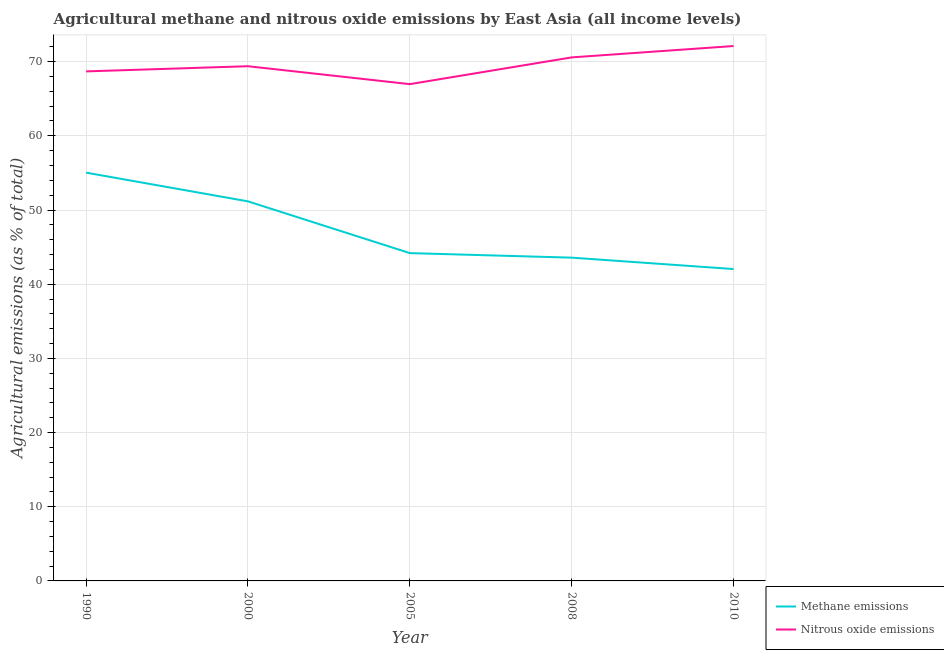Is the number of lines equal to the number of legend labels?
Your response must be concise. Yes. What is the amount of nitrous oxide emissions in 2000?
Make the answer very short. 69.38. Across all years, what is the maximum amount of methane emissions?
Offer a very short reply. 55.04. Across all years, what is the minimum amount of nitrous oxide emissions?
Your answer should be compact. 66.97. In which year was the amount of methane emissions maximum?
Your answer should be compact. 1990. What is the total amount of nitrous oxide emissions in the graph?
Offer a very short reply. 347.72. What is the difference between the amount of methane emissions in 2000 and that in 2010?
Offer a terse response. 9.13. What is the difference between the amount of methane emissions in 2008 and the amount of nitrous oxide emissions in 2000?
Offer a terse response. -25.8. What is the average amount of methane emissions per year?
Your answer should be very brief. 47.2. In the year 2000, what is the difference between the amount of nitrous oxide emissions and amount of methane emissions?
Provide a succinct answer. 18.22. In how many years, is the amount of methane emissions greater than 52 %?
Your answer should be compact. 1. What is the ratio of the amount of nitrous oxide emissions in 1990 to that in 2005?
Your answer should be very brief. 1.03. Is the amount of nitrous oxide emissions in 2005 less than that in 2008?
Keep it short and to the point. Yes. What is the difference between the highest and the second highest amount of nitrous oxide emissions?
Give a very brief answer. 1.53. What is the difference between the highest and the lowest amount of methane emissions?
Your answer should be compact. 13. How many years are there in the graph?
Your response must be concise. 5. What is the difference between two consecutive major ticks on the Y-axis?
Provide a succinct answer. 10. Does the graph contain any zero values?
Provide a short and direct response. No. Does the graph contain grids?
Your answer should be compact. Yes. How many legend labels are there?
Ensure brevity in your answer.  2. How are the legend labels stacked?
Ensure brevity in your answer.  Vertical. What is the title of the graph?
Offer a terse response. Agricultural methane and nitrous oxide emissions by East Asia (all income levels). What is the label or title of the Y-axis?
Provide a short and direct response. Agricultural emissions (as % of total). What is the Agricultural emissions (as % of total) in Methane emissions in 1990?
Your response must be concise. 55.04. What is the Agricultural emissions (as % of total) in Nitrous oxide emissions in 1990?
Provide a succinct answer. 68.69. What is the Agricultural emissions (as % of total) of Methane emissions in 2000?
Offer a very short reply. 51.17. What is the Agricultural emissions (as % of total) of Nitrous oxide emissions in 2000?
Offer a terse response. 69.38. What is the Agricultural emissions (as % of total) of Methane emissions in 2005?
Your answer should be very brief. 44.19. What is the Agricultural emissions (as % of total) in Nitrous oxide emissions in 2005?
Offer a very short reply. 66.97. What is the Agricultural emissions (as % of total) of Methane emissions in 2008?
Offer a terse response. 43.58. What is the Agricultural emissions (as % of total) in Nitrous oxide emissions in 2008?
Your answer should be very brief. 70.57. What is the Agricultural emissions (as % of total) of Methane emissions in 2010?
Make the answer very short. 42.04. What is the Agricultural emissions (as % of total) of Nitrous oxide emissions in 2010?
Provide a succinct answer. 72.11. Across all years, what is the maximum Agricultural emissions (as % of total) in Methane emissions?
Provide a succinct answer. 55.04. Across all years, what is the maximum Agricultural emissions (as % of total) in Nitrous oxide emissions?
Your response must be concise. 72.11. Across all years, what is the minimum Agricultural emissions (as % of total) of Methane emissions?
Offer a very short reply. 42.04. Across all years, what is the minimum Agricultural emissions (as % of total) in Nitrous oxide emissions?
Your answer should be compact. 66.97. What is the total Agricultural emissions (as % of total) of Methane emissions in the graph?
Offer a very short reply. 236.01. What is the total Agricultural emissions (as % of total) in Nitrous oxide emissions in the graph?
Make the answer very short. 347.72. What is the difference between the Agricultural emissions (as % of total) in Methane emissions in 1990 and that in 2000?
Your response must be concise. 3.87. What is the difference between the Agricultural emissions (as % of total) in Nitrous oxide emissions in 1990 and that in 2000?
Offer a very short reply. -0.7. What is the difference between the Agricultural emissions (as % of total) in Methane emissions in 1990 and that in 2005?
Provide a short and direct response. 10.85. What is the difference between the Agricultural emissions (as % of total) of Nitrous oxide emissions in 1990 and that in 2005?
Your answer should be compact. 1.72. What is the difference between the Agricultural emissions (as % of total) in Methane emissions in 1990 and that in 2008?
Offer a very short reply. 11.46. What is the difference between the Agricultural emissions (as % of total) in Nitrous oxide emissions in 1990 and that in 2008?
Your response must be concise. -1.89. What is the difference between the Agricultural emissions (as % of total) in Methane emissions in 1990 and that in 2010?
Offer a very short reply. 13. What is the difference between the Agricultural emissions (as % of total) in Nitrous oxide emissions in 1990 and that in 2010?
Your answer should be very brief. -3.42. What is the difference between the Agricultural emissions (as % of total) in Methane emissions in 2000 and that in 2005?
Offer a very short reply. 6.98. What is the difference between the Agricultural emissions (as % of total) in Nitrous oxide emissions in 2000 and that in 2005?
Offer a terse response. 2.41. What is the difference between the Agricultural emissions (as % of total) in Methane emissions in 2000 and that in 2008?
Give a very brief answer. 7.59. What is the difference between the Agricultural emissions (as % of total) of Nitrous oxide emissions in 2000 and that in 2008?
Make the answer very short. -1.19. What is the difference between the Agricultural emissions (as % of total) of Methane emissions in 2000 and that in 2010?
Offer a very short reply. 9.13. What is the difference between the Agricultural emissions (as % of total) in Nitrous oxide emissions in 2000 and that in 2010?
Your answer should be very brief. -2.72. What is the difference between the Agricultural emissions (as % of total) of Methane emissions in 2005 and that in 2008?
Keep it short and to the point. 0.61. What is the difference between the Agricultural emissions (as % of total) of Nitrous oxide emissions in 2005 and that in 2008?
Your response must be concise. -3.61. What is the difference between the Agricultural emissions (as % of total) in Methane emissions in 2005 and that in 2010?
Offer a very short reply. 2.15. What is the difference between the Agricultural emissions (as % of total) in Nitrous oxide emissions in 2005 and that in 2010?
Ensure brevity in your answer.  -5.14. What is the difference between the Agricultural emissions (as % of total) of Methane emissions in 2008 and that in 2010?
Provide a short and direct response. 1.54. What is the difference between the Agricultural emissions (as % of total) in Nitrous oxide emissions in 2008 and that in 2010?
Keep it short and to the point. -1.53. What is the difference between the Agricultural emissions (as % of total) in Methane emissions in 1990 and the Agricultural emissions (as % of total) in Nitrous oxide emissions in 2000?
Offer a terse response. -14.35. What is the difference between the Agricultural emissions (as % of total) of Methane emissions in 1990 and the Agricultural emissions (as % of total) of Nitrous oxide emissions in 2005?
Your answer should be compact. -11.93. What is the difference between the Agricultural emissions (as % of total) in Methane emissions in 1990 and the Agricultural emissions (as % of total) in Nitrous oxide emissions in 2008?
Give a very brief answer. -15.54. What is the difference between the Agricultural emissions (as % of total) in Methane emissions in 1990 and the Agricultural emissions (as % of total) in Nitrous oxide emissions in 2010?
Your answer should be compact. -17.07. What is the difference between the Agricultural emissions (as % of total) of Methane emissions in 2000 and the Agricultural emissions (as % of total) of Nitrous oxide emissions in 2005?
Offer a very short reply. -15.8. What is the difference between the Agricultural emissions (as % of total) in Methane emissions in 2000 and the Agricultural emissions (as % of total) in Nitrous oxide emissions in 2008?
Offer a very short reply. -19.41. What is the difference between the Agricultural emissions (as % of total) of Methane emissions in 2000 and the Agricultural emissions (as % of total) of Nitrous oxide emissions in 2010?
Keep it short and to the point. -20.94. What is the difference between the Agricultural emissions (as % of total) of Methane emissions in 2005 and the Agricultural emissions (as % of total) of Nitrous oxide emissions in 2008?
Provide a succinct answer. -26.38. What is the difference between the Agricultural emissions (as % of total) of Methane emissions in 2005 and the Agricultural emissions (as % of total) of Nitrous oxide emissions in 2010?
Your answer should be compact. -27.91. What is the difference between the Agricultural emissions (as % of total) in Methane emissions in 2008 and the Agricultural emissions (as % of total) in Nitrous oxide emissions in 2010?
Offer a terse response. -28.53. What is the average Agricultural emissions (as % of total) of Methane emissions per year?
Provide a succinct answer. 47.2. What is the average Agricultural emissions (as % of total) of Nitrous oxide emissions per year?
Offer a terse response. 69.54. In the year 1990, what is the difference between the Agricultural emissions (as % of total) in Methane emissions and Agricultural emissions (as % of total) in Nitrous oxide emissions?
Provide a succinct answer. -13.65. In the year 2000, what is the difference between the Agricultural emissions (as % of total) in Methane emissions and Agricultural emissions (as % of total) in Nitrous oxide emissions?
Ensure brevity in your answer.  -18.22. In the year 2005, what is the difference between the Agricultural emissions (as % of total) in Methane emissions and Agricultural emissions (as % of total) in Nitrous oxide emissions?
Provide a succinct answer. -22.78. In the year 2008, what is the difference between the Agricultural emissions (as % of total) of Methane emissions and Agricultural emissions (as % of total) of Nitrous oxide emissions?
Offer a very short reply. -27. In the year 2010, what is the difference between the Agricultural emissions (as % of total) in Methane emissions and Agricultural emissions (as % of total) in Nitrous oxide emissions?
Keep it short and to the point. -30.06. What is the ratio of the Agricultural emissions (as % of total) of Methane emissions in 1990 to that in 2000?
Make the answer very short. 1.08. What is the ratio of the Agricultural emissions (as % of total) in Nitrous oxide emissions in 1990 to that in 2000?
Provide a short and direct response. 0.99. What is the ratio of the Agricultural emissions (as % of total) in Methane emissions in 1990 to that in 2005?
Your answer should be compact. 1.25. What is the ratio of the Agricultural emissions (as % of total) in Nitrous oxide emissions in 1990 to that in 2005?
Provide a short and direct response. 1.03. What is the ratio of the Agricultural emissions (as % of total) of Methane emissions in 1990 to that in 2008?
Provide a short and direct response. 1.26. What is the ratio of the Agricultural emissions (as % of total) of Nitrous oxide emissions in 1990 to that in 2008?
Your response must be concise. 0.97. What is the ratio of the Agricultural emissions (as % of total) in Methane emissions in 1990 to that in 2010?
Ensure brevity in your answer.  1.31. What is the ratio of the Agricultural emissions (as % of total) of Nitrous oxide emissions in 1990 to that in 2010?
Offer a terse response. 0.95. What is the ratio of the Agricultural emissions (as % of total) of Methane emissions in 2000 to that in 2005?
Offer a very short reply. 1.16. What is the ratio of the Agricultural emissions (as % of total) in Nitrous oxide emissions in 2000 to that in 2005?
Ensure brevity in your answer.  1.04. What is the ratio of the Agricultural emissions (as % of total) in Methane emissions in 2000 to that in 2008?
Provide a short and direct response. 1.17. What is the ratio of the Agricultural emissions (as % of total) in Nitrous oxide emissions in 2000 to that in 2008?
Your answer should be very brief. 0.98. What is the ratio of the Agricultural emissions (as % of total) in Methane emissions in 2000 to that in 2010?
Offer a very short reply. 1.22. What is the ratio of the Agricultural emissions (as % of total) in Nitrous oxide emissions in 2000 to that in 2010?
Keep it short and to the point. 0.96. What is the ratio of the Agricultural emissions (as % of total) in Methane emissions in 2005 to that in 2008?
Offer a very short reply. 1.01. What is the ratio of the Agricultural emissions (as % of total) in Nitrous oxide emissions in 2005 to that in 2008?
Your answer should be compact. 0.95. What is the ratio of the Agricultural emissions (as % of total) of Methane emissions in 2005 to that in 2010?
Make the answer very short. 1.05. What is the ratio of the Agricultural emissions (as % of total) in Nitrous oxide emissions in 2005 to that in 2010?
Give a very brief answer. 0.93. What is the ratio of the Agricultural emissions (as % of total) of Methane emissions in 2008 to that in 2010?
Your response must be concise. 1.04. What is the ratio of the Agricultural emissions (as % of total) in Nitrous oxide emissions in 2008 to that in 2010?
Make the answer very short. 0.98. What is the difference between the highest and the second highest Agricultural emissions (as % of total) in Methane emissions?
Your answer should be compact. 3.87. What is the difference between the highest and the second highest Agricultural emissions (as % of total) in Nitrous oxide emissions?
Keep it short and to the point. 1.53. What is the difference between the highest and the lowest Agricultural emissions (as % of total) of Methane emissions?
Keep it short and to the point. 13. What is the difference between the highest and the lowest Agricultural emissions (as % of total) of Nitrous oxide emissions?
Your answer should be very brief. 5.14. 